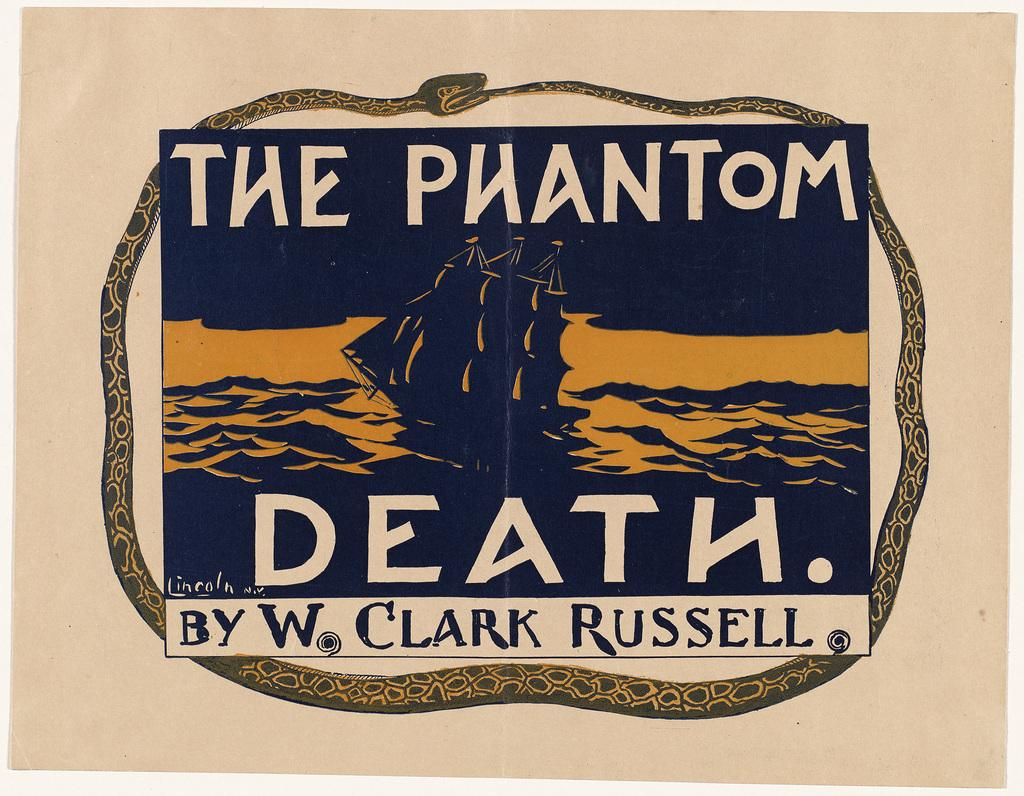What is present on the paper in the image? There is a paper in the image, and it has a picture on it. What else can be seen on the paper besides the picture? The paper has text on it. Can you describe the location of the text on the paper? The text is located at the top and bottom of the paper. What type of pie is being served to the team in the image? There is no pie or team present in the image; it features a paper with a picture and text. How many members of the low team are visible in the image? There is no low team present in the image. 